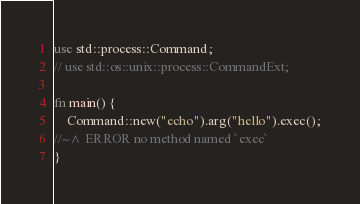Convert code to text. <code><loc_0><loc_0><loc_500><loc_500><_Rust_>use std::process::Command;
// use std::os::unix::process::CommandExt;

fn main() {
    Command::new("echo").arg("hello").exec();
//~^ ERROR no method named `exec`
}
</code> 